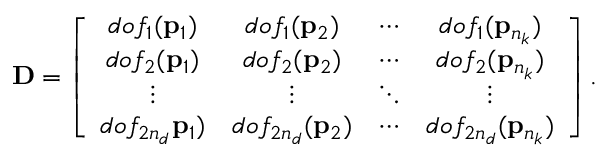Convert formula to latex. <formula><loc_0><loc_0><loc_500><loc_500>D = \left [ \begin{array} { c c c c } { d o f _ { 1 } ( p _ { 1 } ) } & { d o f _ { 1 } ( p _ { 2 } ) } & { \cdots } & { d o f _ { 1 } ( p _ { n _ { k } } ) } \\ { d o f _ { 2 } ( p _ { 1 } ) } & { d o f _ { 2 } ( p _ { 2 } ) } & { \cdots } & { d o f _ { 2 } ( p _ { n _ { k } } ) } \\ { \vdots } & { \vdots } & { \ddots } & { \vdots } \\ { d o f _ { 2 n _ { d } } p _ { 1 } ) } & { d o f _ { 2 n _ { d } } ( p _ { 2 } ) } & { \cdots } & { d o f _ { 2 n _ { d } } ( p _ { n _ { k } } ) } \end{array} \right ] .</formula> 